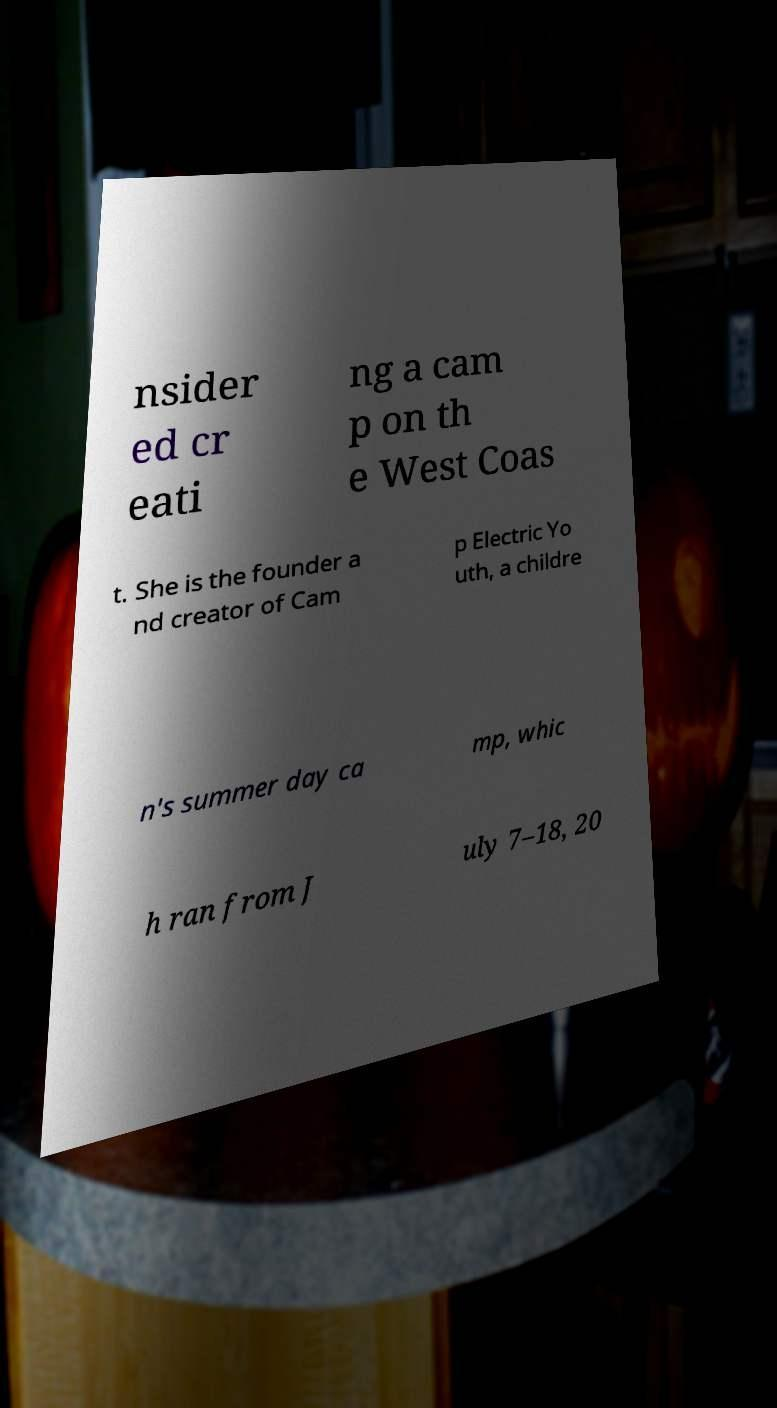I need the written content from this picture converted into text. Can you do that? nsider ed cr eati ng a cam p on th e West Coas t. She is the founder a nd creator of Cam p Electric Yo uth, a childre n's summer day ca mp, whic h ran from J uly 7–18, 20 